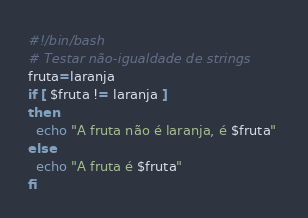Convert code to text. <code><loc_0><loc_0><loc_500><loc_500><_Bash_>#!/bin/bash
# Testar não-igualdade de strings
fruta=laranja
if [ $fruta != laranja ]
then
  echo "A fruta não é laranja, é $fruta" 
else
  echo "A fruta é $fruta"
fi
</code> 